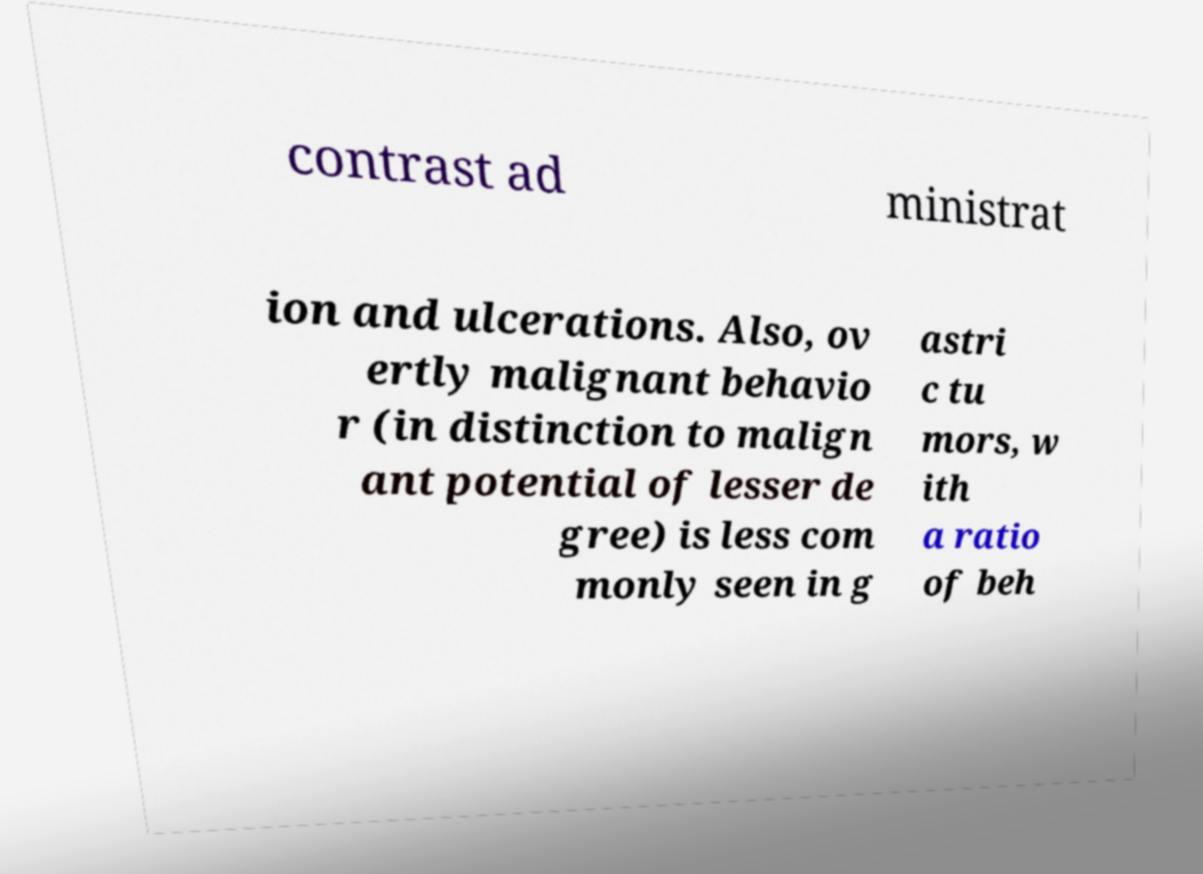There's text embedded in this image that I need extracted. Can you transcribe it verbatim? contrast ad ministrat ion and ulcerations. Also, ov ertly malignant behavio r (in distinction to malign ant potential of lesser de gree) is less com monly seen in g astri c tu mors, w ith a ratio of beh 